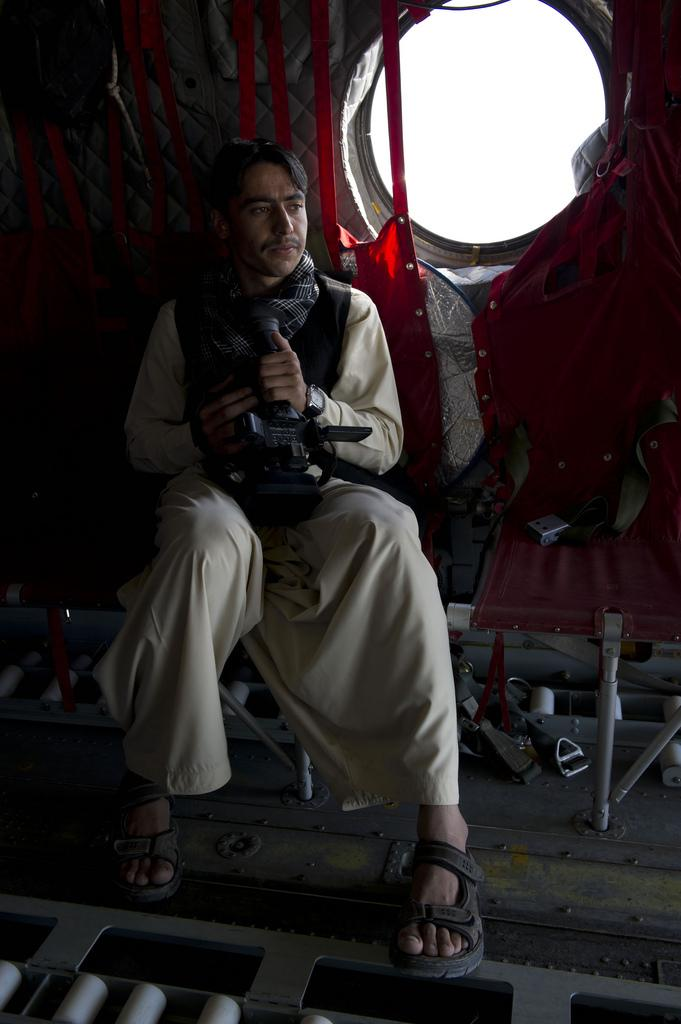Who or what is present in the image? There is a person in the image. What is the person doing in the image? The person is sitting and holding something. What can be seen in the background of the image? There is a window in the image. What color is the cloth visible in the image? The cloth in the image is red. What type of match is being played in the image? There is no match being played in the image; it features a person sitting and holding something. 